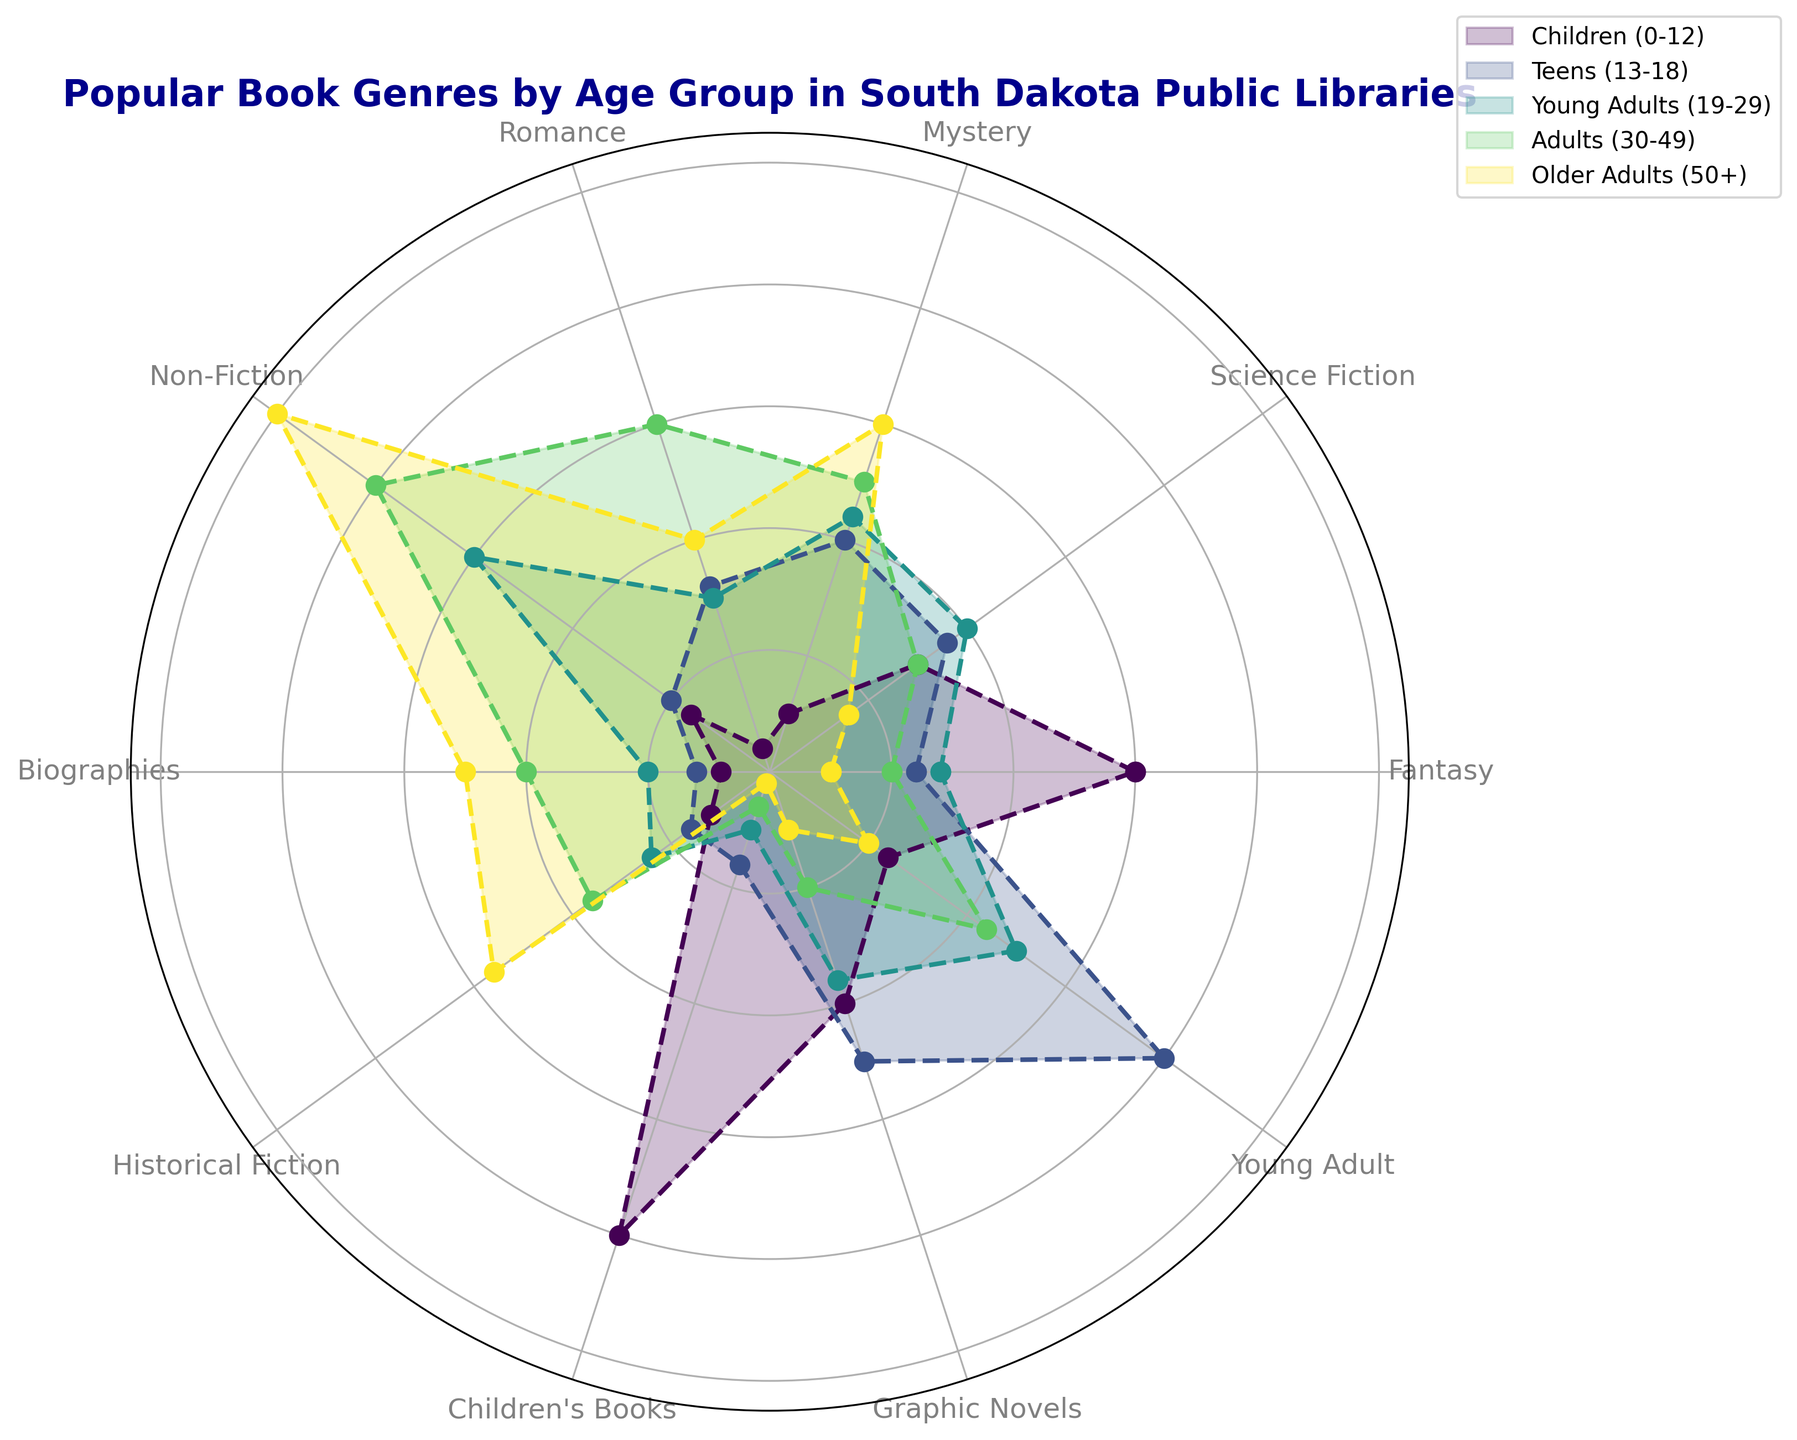Which age group checks out the most Romance books? By examining the plot, we see that the adults (30-49) have the outermost (longest) segment for the Romance genre.
Answer: Adults (30-49) Which genre do Teens (13-18) check out the most? Looking at the teenagers' color on the plot, the segment for Young Adult is the longest.
Answer: Young Adult What is the difference in the number of Historical Fictions checked out by Adults (30-49) compared to Older Adults (50+)? From the plot, Adults (30-49) check out Historical Fiction books with a value of 18, while Older Adults (50+) have a value of 28. The difference is 28 - 18 = 10.
Answer: 10 Which three genres have the highest values for the Children (0-12) age group? Observing the segments for children, the longest three segments are for Children's Books, Fantasy, and Graphic Novels.
Answer: Children's Books, Fantasy, Graphic Novels Do Young Adults (19-29) check out more Non-Fiction or Science Fiction books? Checking the lengths of the corresponding segments, Young Adults check out Non-Fiction books (30) more than Science Fiction books (20).
Answer: Non-Fiction What is the total number of genres where Older Adults (50+) have the highest values? By inspecting each segment, Older Adults (50+) have the highest values in Mystery, Non-Fiction, Biographies, and Historical Fiction, making a total of 4 genres.
Answer: 4 Which age group has the least interest in Children's Books? The plot shows that Older Adults (50+) have the shortest segment for Children's Books with a value of 1.
Answer: Older Adults (50+) What is the combined value for Fantasy and Biographies for Teens (13-18)? Teens (13-18) have values for Fantasy (12) and Biographies (6). Therefore, the combined value is 12 + 6 = 18.
Answer: 18 How many genres do Kids (0-12) check out more of than Older Adults (50+)? By comparing each genre segment, Kids (0-12) check out more in Fantasy, Science Fiction, Romance, Children's Books, and Graphic Novels, which make 5 genres.
Answer: 5 For which genre do Adults (30-49) and Young Adults (19-29) have almost equal check-out values? Observing the plot, both Adults (30-49) and Young Adults (19-29) similarly check out Mystery books, with values close to each other (25 and 22 respectively).
Answer: Mystery 